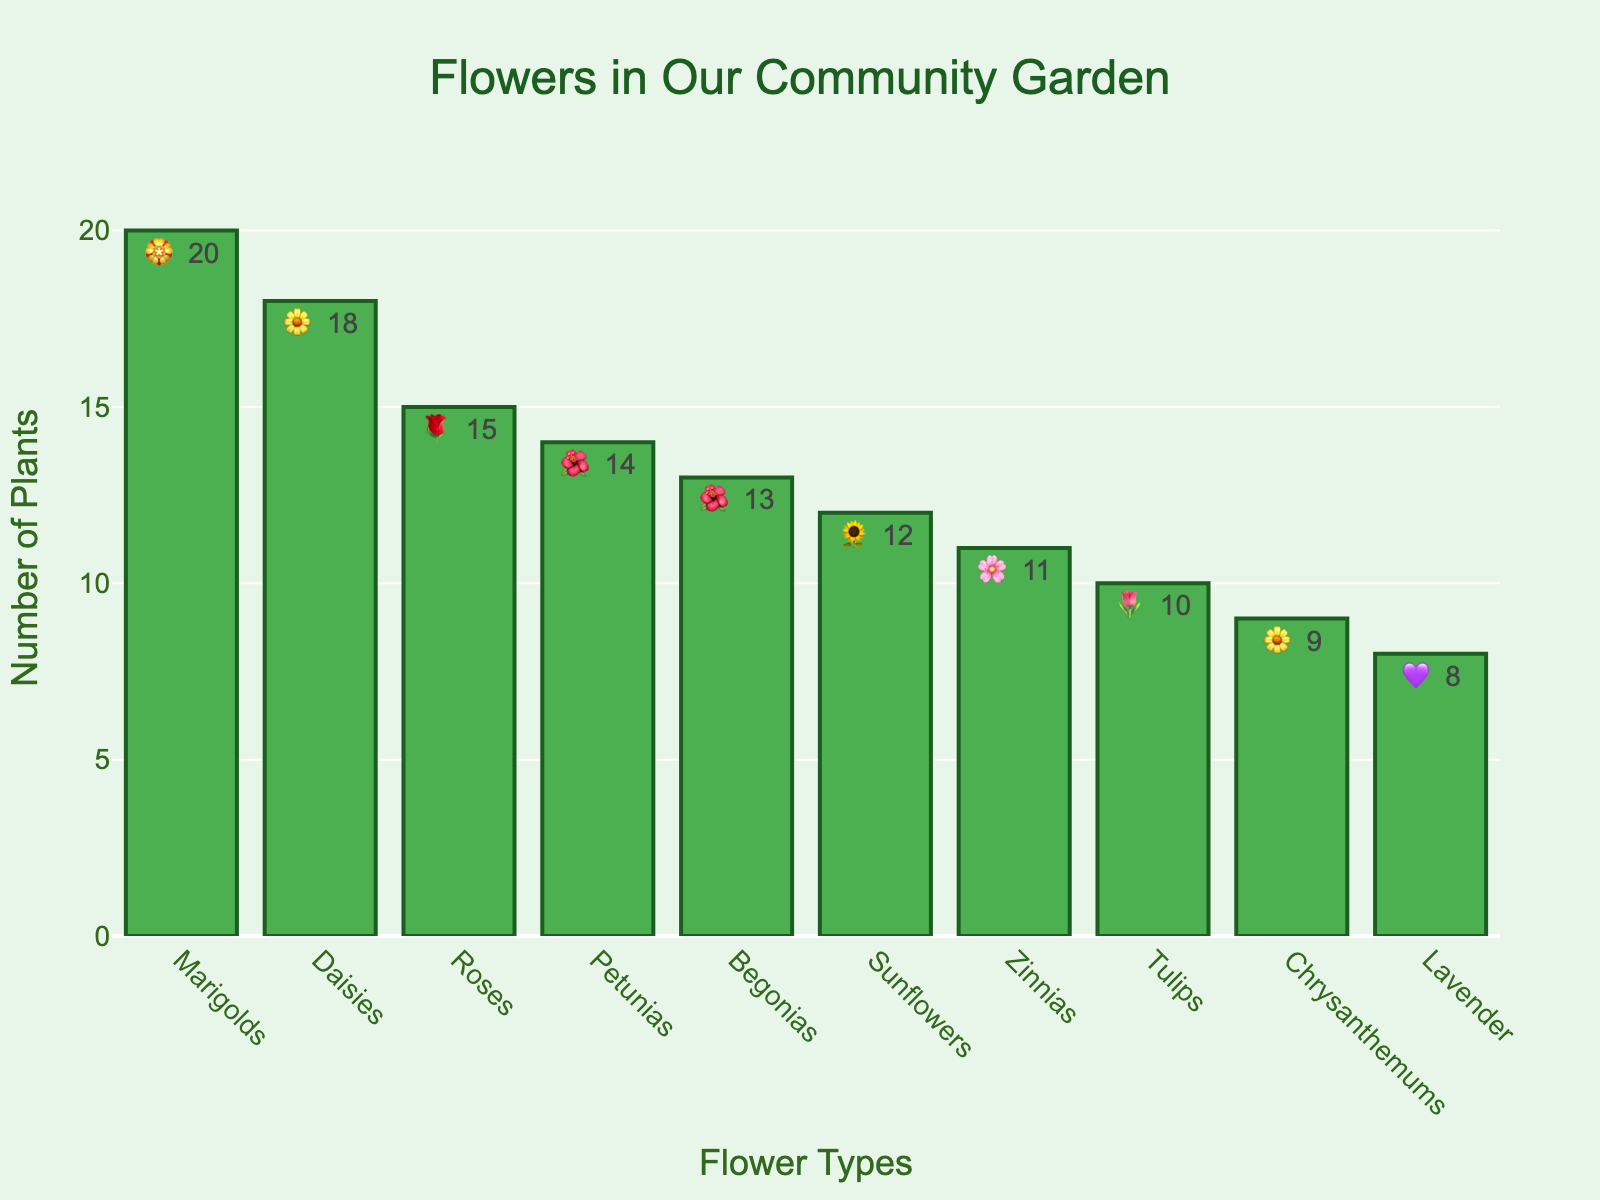Which flower type is the most grown in the community garden? By observing the highest bar in the bar chart, we can see that Marigolds have the highest count with 20 plants.
Answer: Marigolds How many more Daisies are grown compared to Tulips? First, identify the counts: Daisies have 18 plants and Tulips have 10. Then, subtract the count of Tulips from the count of Daisies: 18 - 10 = 8.
Answer: 8 What is the total number of all flower plants grown in the community garden? Sum the counts of all flower types: 15 (Roses) + 12 (Sunflowers) + 20 (Marigolds) + 18 (Daisies) + 10 (Tulips) + 8 (Lavender) + 14 (Petunias) + 11 (Zinnias) + 9 (Chrysanthemums) + 13 (Begonias) = 130.
Answer: 130 Which flower type has the third highest count and how many are there? The third highest count is for Daisies with 18 plants, following Marigolds (20) and Roses (15).
Answer: Daisies, 18 Are there more Roses or Petunias grown in the community garden? By comparing the bar heights for Roses and Petunias, Roses have 15 and Petunias have 14. Therefore, there are more Roses.
Answer: Roses What two flower types have the lowest counts, and what are their counts? By observing the shortest two bars, the lowest counts are for Lavender with 8 plants and Chrysanthemums with 9 plants.
Answer: Lavender, 8; Chrysanthemums, 9 If the number of Zinnias was doubled, how would their count compare to Marigolds? Doubling the Zinnias count gives 11 * 2 = 22. Since Marigolds have 20, 22 is greater than 20.
Answer: Zinnias would have more What is the combined total of Sunflowers and Begonias? By adding the counts: 12 (Sunflowers) + 13 (Begonias) = 25.
Answer: 25 Which flower types have the same emoji representation in the chart? Both Daisies and Chrysanthemums share the same emoji representation 🌼.
Answer: Daisies and Chrysanthemums 